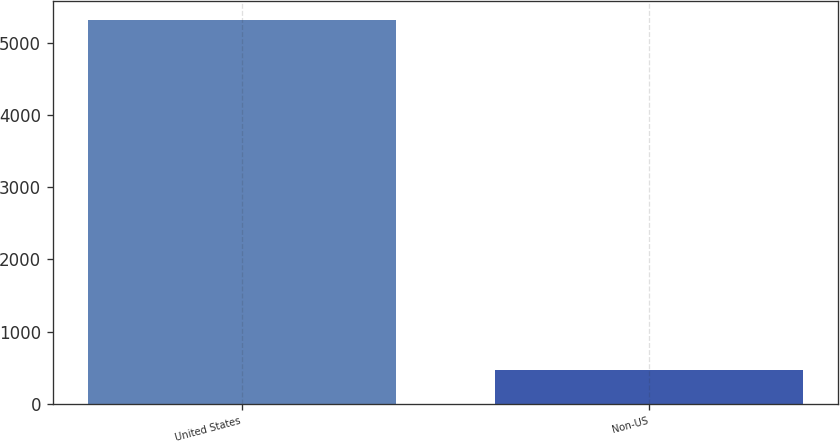Convert chart. <chart><loc_0><loc_0><loc_500><loc_500><bar_chart><fcel>United States<fcel>Non-US<nl><fcel>5309<fcel>467<nl></chart> 